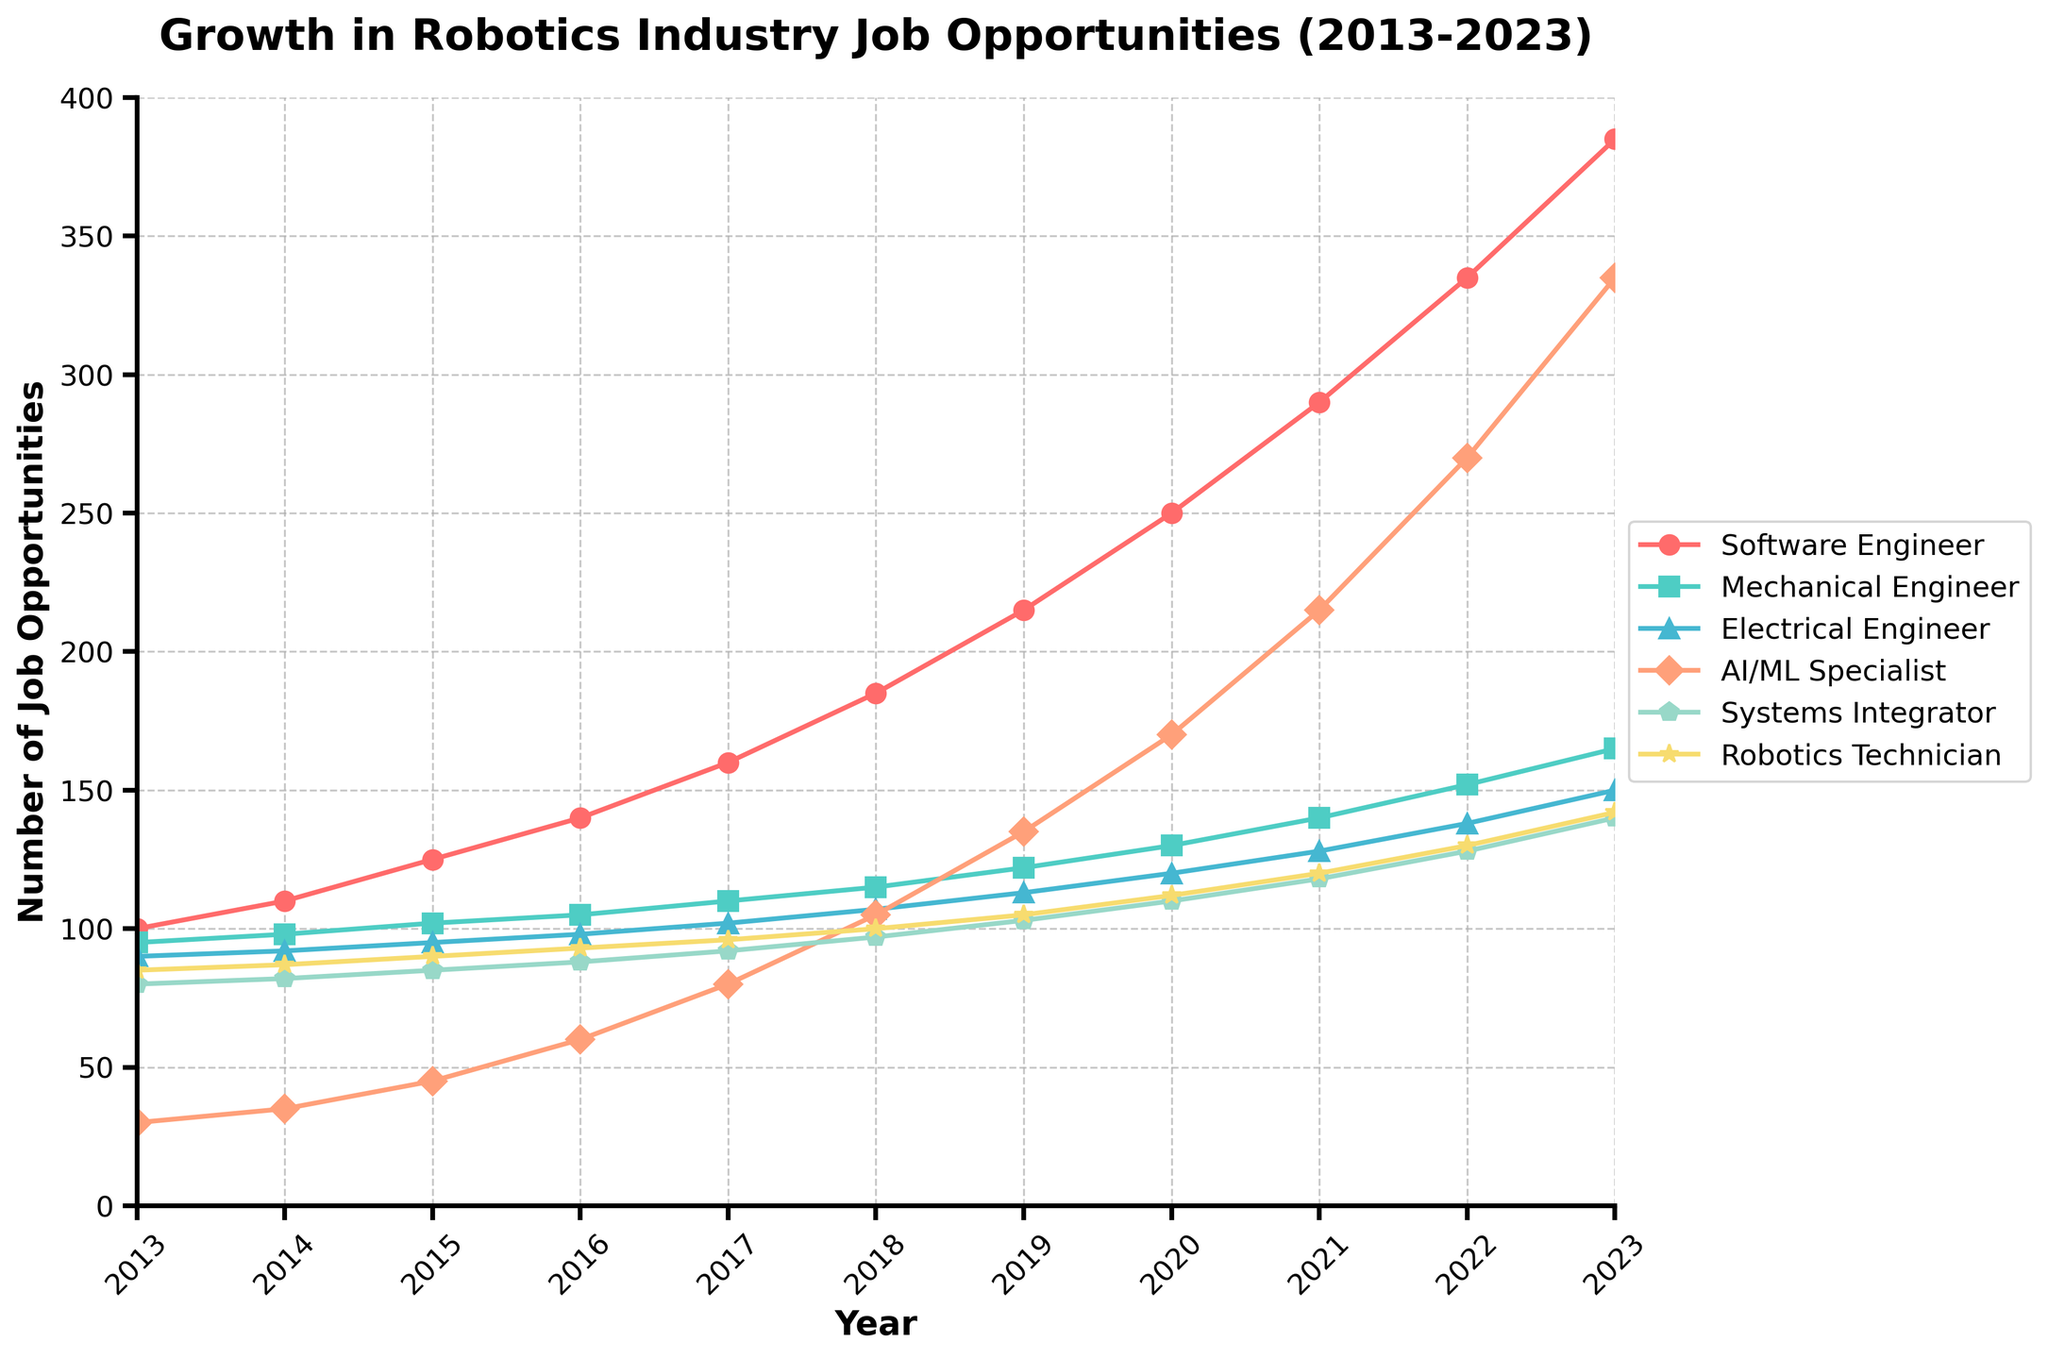Which specialization experienced the highest growth in job opportunities from 2013 to 2023? Observe the lines, AI/ML Specialist shows the steepest increase from 30 in 2013 to 335 in 2023.
Answer: AI/ML Specialist By how many job opportunities did the number of Software Engineer positions increase from 2015 to 2020? In 2015, Software Engineer positions were 125. In 2020, they were 250. Subtract 125 from 250 to find the increase.
Answer: 125 Which specialization had the smallest number of job opportunities in 2023? Compare the final data points of each line for the year 2023. Electrical Engineer has the smallest value at 150.
Answer: Electrical Engineer How did the job opportunities for Systems Integrator change from 2014 to 2019? In 2014, Systems Integrator had 82 opportunities, and in 2019, it had 103. Subtract 82 from 103 to determine the change.
Answer: Increased by 21 Between which two consecutive years did the AI/ML Specialist positions see the highest increase? By observing the steepness of the line between consecutive years, the largest jump appears between 2020 (170) and 2021 (215). Calculate 215 - 170.
Answer: 2020 to 2021 Compare the growth trend of Mechanical Engineer and Robotics Technician from 2013 to 2023. Which had more consistent year-over-year growth? Inspect the two lines for year-over-year smoothness. Mechanical Engineer's line shows more gradual, uniform increments every year compared to Robotics Technician.
Answer: Mechanical Engineer If we consider the start (2013) and end (2023) values, what is the average annual increase in job opportunities for AI/ML Specialist? Initial value (30) and final value (335). The interval is 10 years. Calculate (335 - 30) / 10.
Answer: 30.5 Which specialization saw the least visual change on the plot between 2013 and 2018? Look for the flattest line between 2013 and 2018. Electrical Engineer shows minimal change visually, increasing from 90 to 107.
Answer: Electrical Engineer What is the ratio of the number of Software Engineer opportunities to Robotics Technician opportunities in 2023? For 2023, Software Engineer has 385 opportunities and Robotics Technician has 142. Divide 385 by 142.
Answer: 2.71 By how many job opportunities did the number of Systems Integrator positions increase from 2017 to 2023? In 2017, Systems Integrator had 92 opportunities. In 2023, it had 140. Subtract 92 from 140.
Answer: 48 